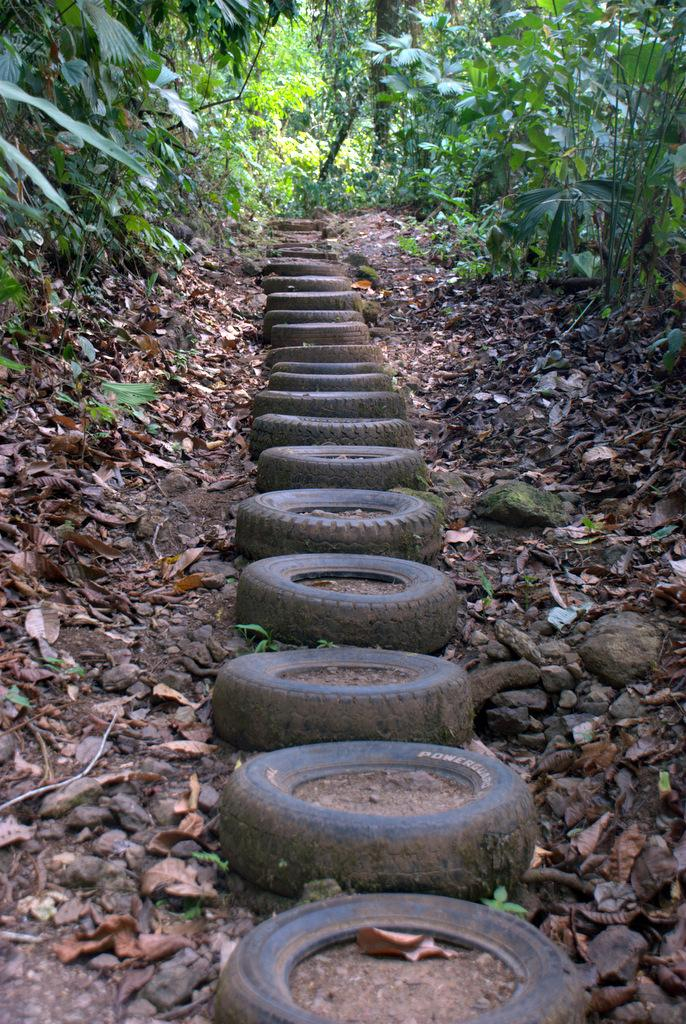What objects can be seen in the image that are typically used for transportation? There are tyres in the image, which are commonly used for transportation. What type of organic material is present in the image? There are shredded leaves in the image. What type of inorganic material is present in the image? Stones are visible in the image. What type of living organisms can be seen in the image? There are plants in the image. What type of pet can be seen in the image? There is no pet present in the image. What is the answer to the question about the test in the image? There is no test or question about a test in the image. 